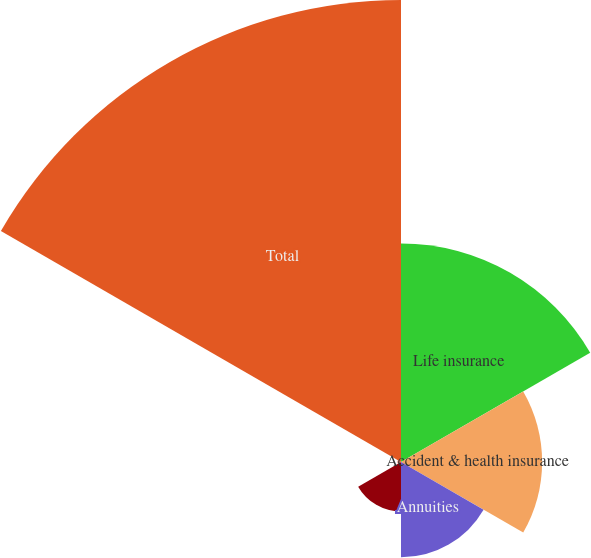<chart> <loc_0><loc_0><loc_500><loc_500><pie_chart><fcel>Life insurance<fcel>Accident & health insurance<fcel>Annuities<fcel>Property and casualty<fcel>Non-insurance<fcel>Total<nl><fcel>22.52%<fcel>14.55%<fcel>9.83%<fcel>5.1%<fcel>0.37%<fcel>47.63%<nl></chart> 